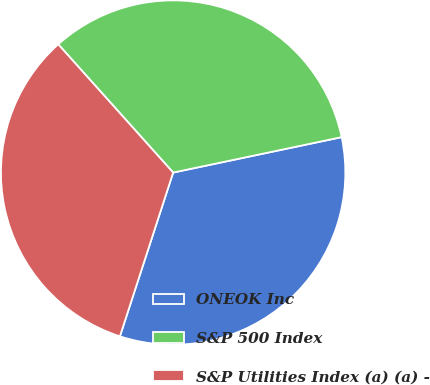<chart> <loc_0><loc_0><loc_500><loc_500><pie_chart><fcel>ONEOK Inc<fcel>S&P 500 Index<fcel>S&P Utilities Index (a) (a) -<nl><fcel>33.3%<fcel>33.33%<fcel>33.37%<nl></chart> 